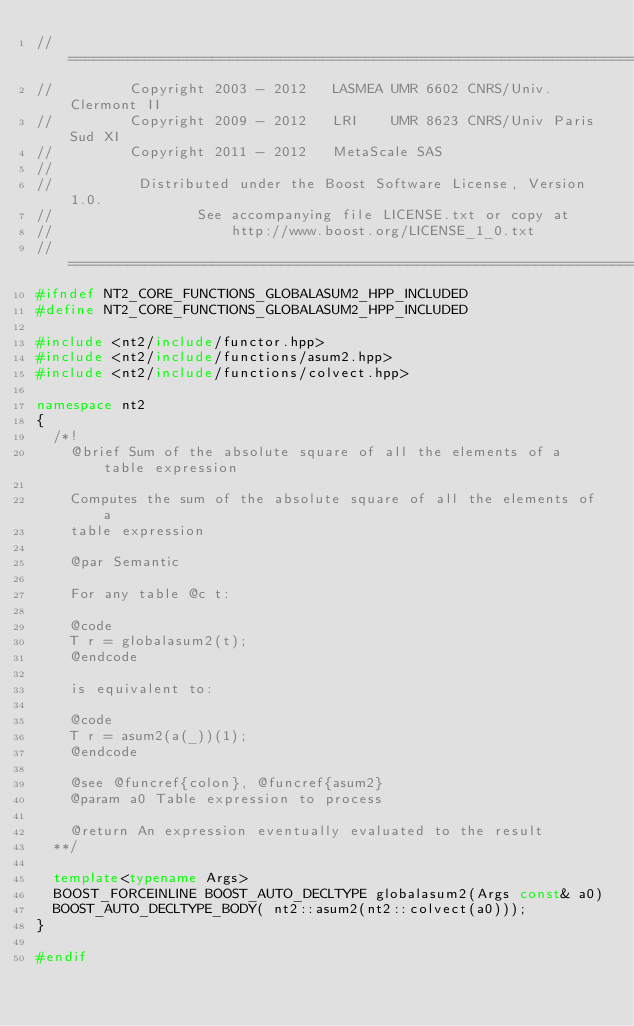<code> <loc_0><loc_0><loc_500><loc_500><_C++_>//==============================================================================
//         Copyright 2003 - 2012   LASMEA UMR 6602 CNRS/Univ. Clermont II
//         Copyright 2009 - 2012   LRI    UMR 8623 CNRS/Univ Paris Sud XI
//         Copyright 2011 - 2012   MetaScale SAS
//
//          Distributed under the Boost Software License, Version 1.0.
//                 See accompanying file LICENSE.txt or copy at
//                     http://www.boost.org/LICENSE_1_0.txt
//==============================================================================
#ifndef NT2_CORE_FUNCTIONS_GLOBALASUM2_HPP_INCLUDED
#define NT2_CORE_FUNCTIONS_GLOBALASUM2_HPP_INCLUDED

#include <nt2/include/functor.hpp>
#include <nt2/include/functions/asum2.hpp>
#include <nt2/include/functions/colvect.hpp>

namespace nt2
{
  /*!
    @brief Sum of the absolute square of all the elements of a table expression

    Computes the sum of the absolute square of all the elements of a
    table expression

    @par Semantic

    For any table @c t:

    @code
    T r = globalasum2(t);
    @endcode

    is equivalent to:

    @code
    T r = asum2(a(_))(1);
    @endcode

    @see @funcref{colon}, @funcref{asum2}
    @param a0 Table expression to process

    @return An expression eventually evaluated to the result
  **/

  template<typename Args>
  BOOST_FORCEINLINE BOOST_AUTO_DECLTYPE globalasum2(Args const& a0)
  BOOST_AUTO_DECLTYPE_BODY( nt2::asum2(nt2::colvect(a0)));
}

#endif
</code> 